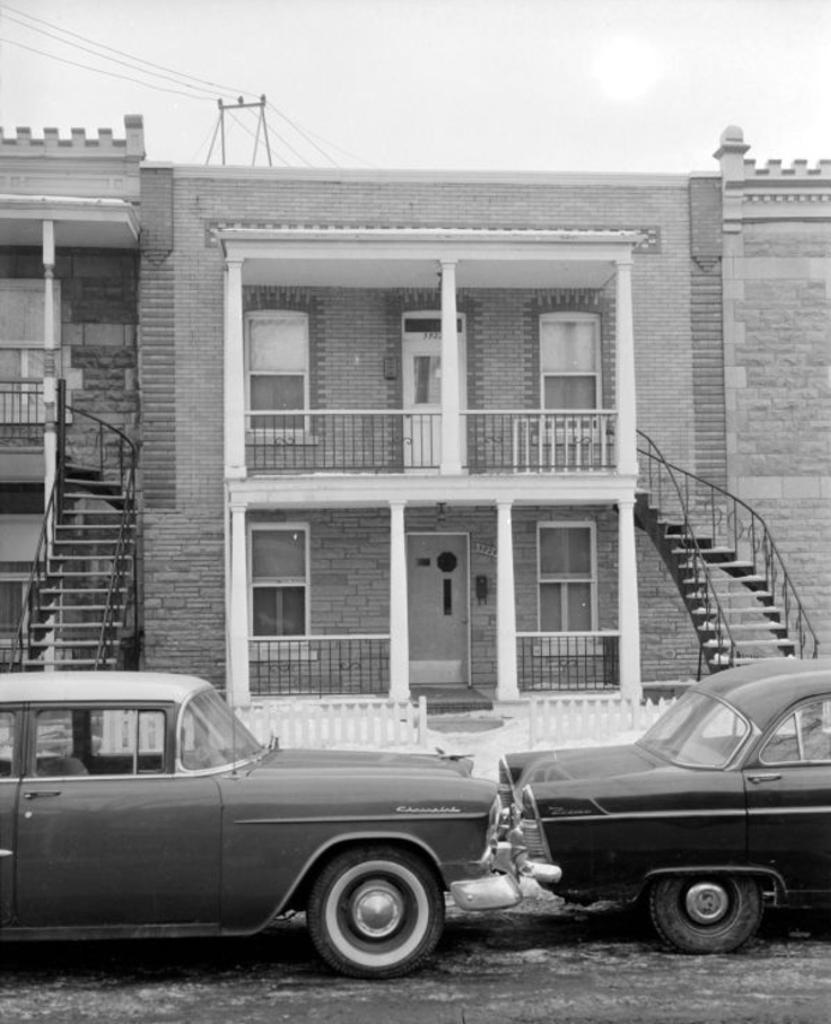What is the color scheme of the image? The image is black and white. What vehicles are present in the image? There are two cars in the bottom of the image. What type of structures can be seen in the background? There are buildings in the background of the image. What is visible at the top of the image? The sky is visible at the top of the image. How many straws are being used by the rabbits in the image? There are no rabbits or straws present in the image. 